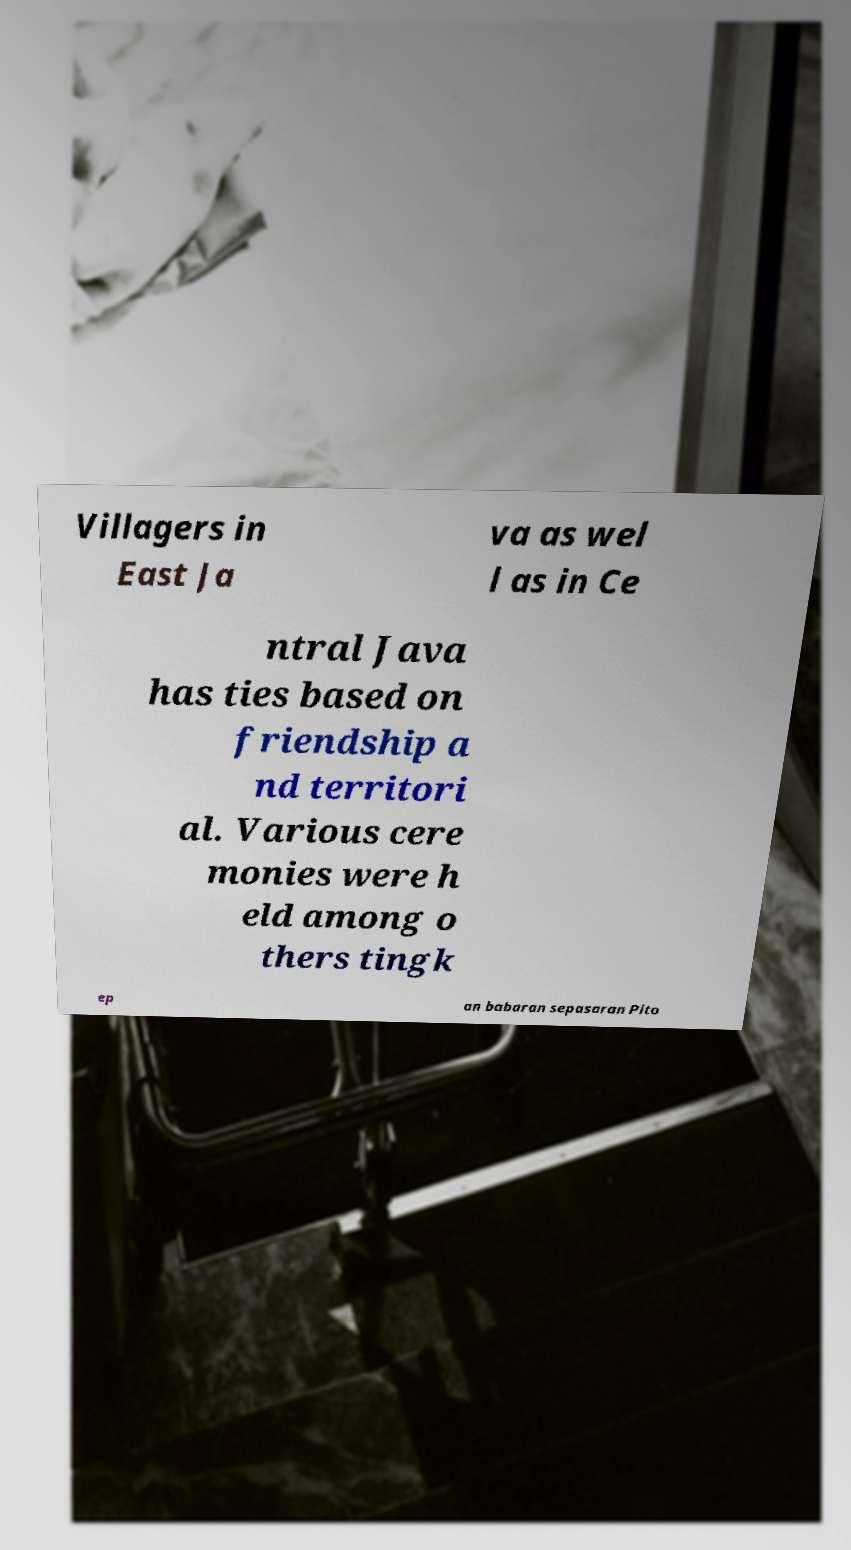Can you read and provide the text displayed in the image?This photo seems to have some interesting text. Can you extract and type it out for me? Villagers in East Ja va as wel l as in Ce ntral Java has ties based on friendship a nd territori al. Various cere monies were h eld among o thers tingk ep an babaran sepasaran Pito 